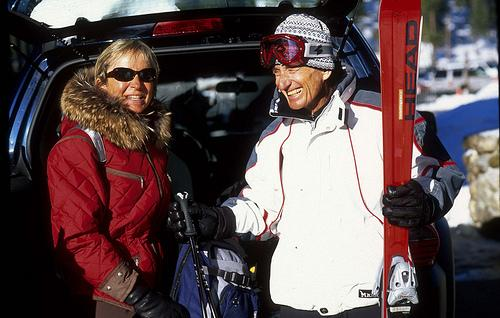Count the number of hands visible in the image. There are four hands visible in the image. How many people are smiling in the image, and what are they wearing on their heads? Two people are smiling in the image - one man with a big smile has a grey hat on his head, and a blond woman with short hair has no noticeable headwear. Identify the type of winter clothing on a person in the image. A man is dressed in a white and red jacket, wearing a grey hat and black bulky gloves. Mention an object that the woman in the red furry coat is wearing and holding. The woman in the red furry coat is wearing sunglasses over her eyes and holding a blue backpack. What are some objects that people appear to be holding in the image? Some objects being held in the image include red snow skis, ski poles, a blue backpack, and a black metal ski pole. What are some distinctive features of the man wearing the white and red coat? The man in the white and red coat has a big smile on his face, is wearing a grey hat, red and grey goggles, and black bulky gloves. Tell me about the pairs of glasses in the image. There are two pairs of glasses: one on a woman with sunglasses over her eyes, and the other is red and grey goggles on a man's head. What is the man in the red ski mask doing? The man in the red ski mask is wearing goggles around his head and holding red snow skis and ski poles in his hand. Describe the inside of the car in the image. The inside of the car features a rear view mirror, and there is a visible rear break light at the top of the car as well. Describe the backpack in the image. There is a blue backpack with black buckles in the image, held by a woman in a red furry coat. 